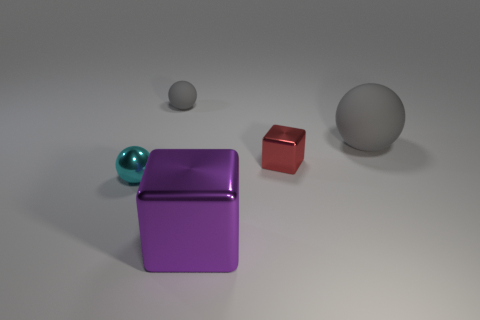Add 2 red cubes. How many objects exist? 7 Subtract all blocks. How many objects are left? 3 Subtract all cyan metal things. Subtract all big brown metal things. How many objects are left? 4 Add 1 metal objects. How many metal objects are left? 4 Add 3 large purple shiny cubes. How many large purple shiny cubes exist? 4 Subtract 1 red blocks. How many objects are left? 4 